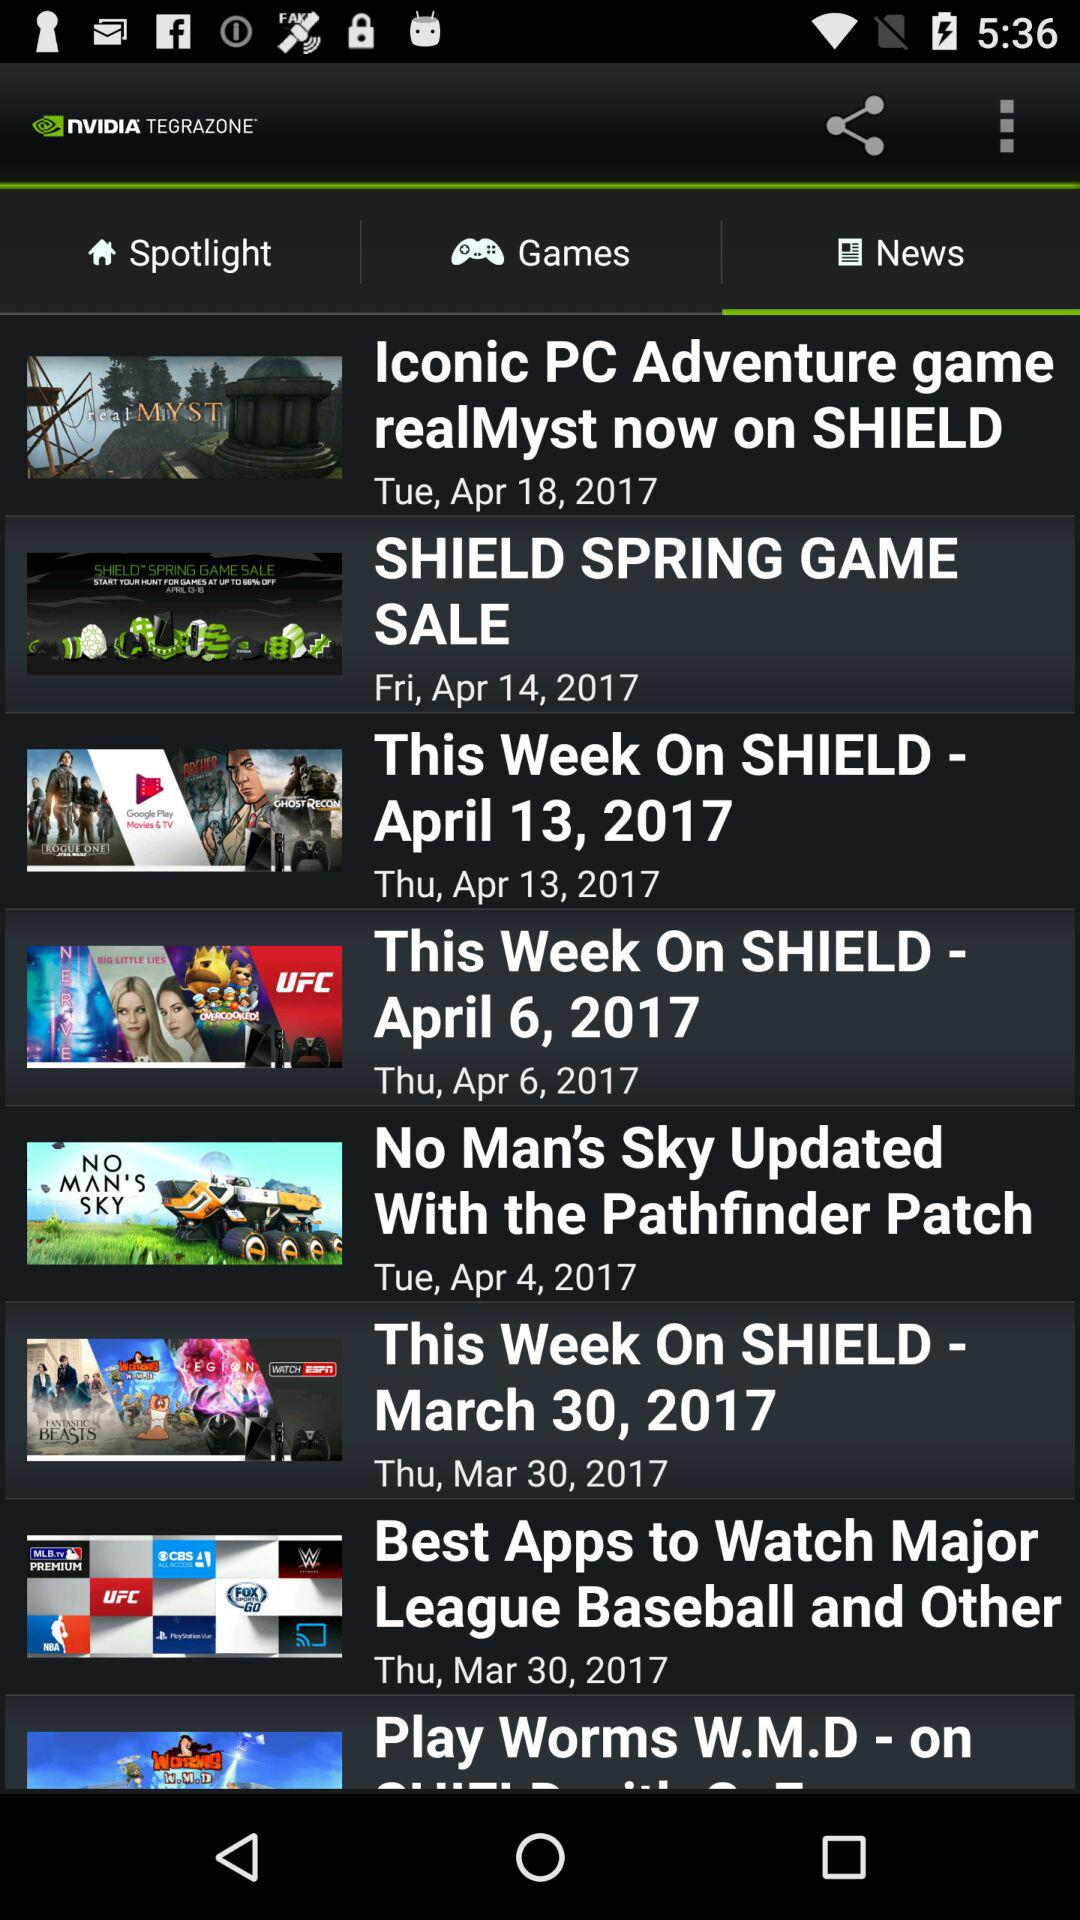What is the news on Friday, 14th April 2017? The news is "SHIELD SPRING GAME SALE". 